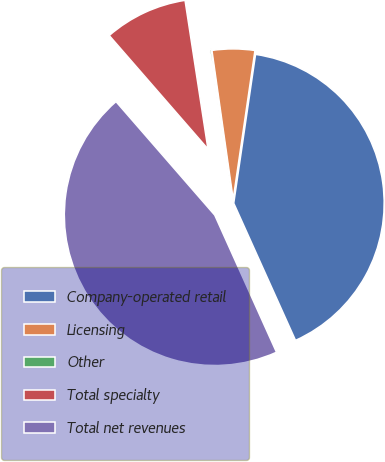Convert chart. <chart><loc_0><loc_0><loc_500><loc_500><pie_chart><fcel>Company-operated retail<fcel>Licensing<fcel>Other<fcel>Total specialty<fcel>Total net revenues<nl><fcel>40.95%<fcel>4.57%<fcel>0.18%<fcel>8.96%<fcel>45.34%<nl></chart> 